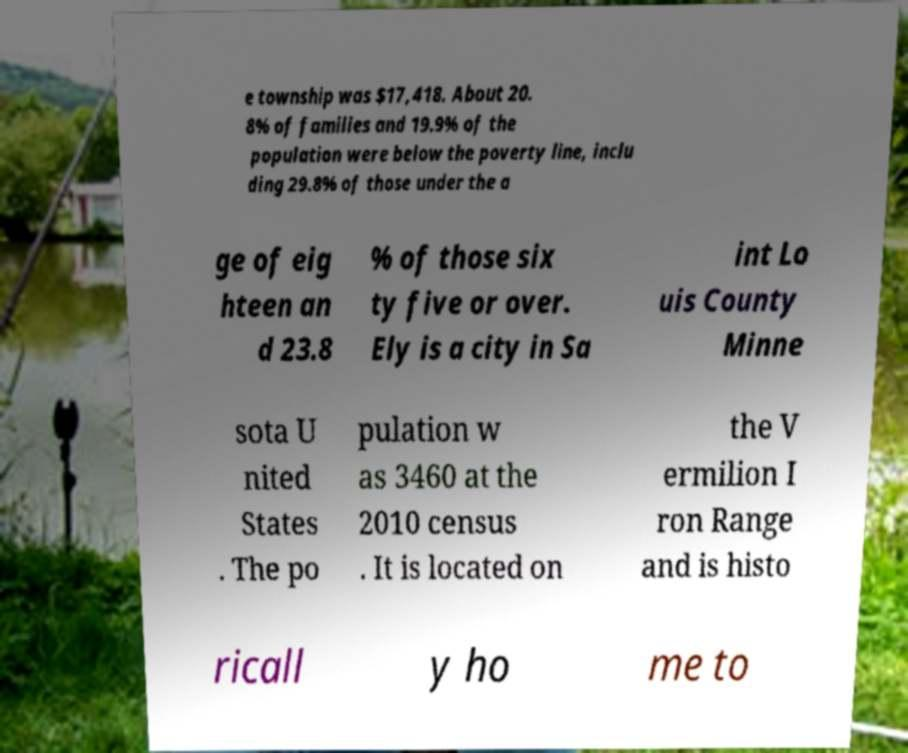Could you assist in decoding the text presented in this image and type it out clearly? e township was $17,418. About 20. 8% of families and 19.9% of the population were below the poverty line, inclu ding 29.8% of those under the a ge of eig hteen an d 23.8 % of those six ty five or over. Ely is a city in Sa int Lo uis County Minne sota U nited States . The po pulation w as 3460 at the 2010 census . It is located on the V ermilion I ron Range and is histo ricall y ho me to 